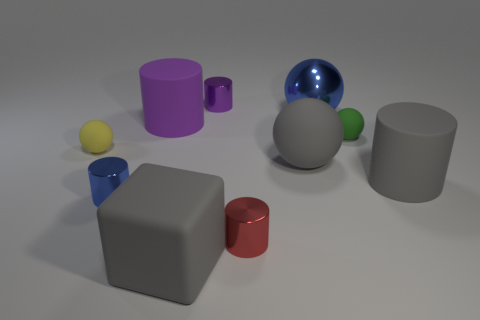Subtract all purple cylinders. How many were subtracted if there are1purple cylinders left? 1 Subtract 1 cylinders. How many cylinders are left? 4 Subtract all spheres. How many objects are left? 6 Subtract 0 purple blocks. How many objects are left? 10 Subtract all red shiny cylinders. Subtract all small metallic cylinders. How many objects are left? 6 Add 1 cubes. How many cubes are left? 2 Add 5 brown shiny things. How many brown shiny things exist? 5 